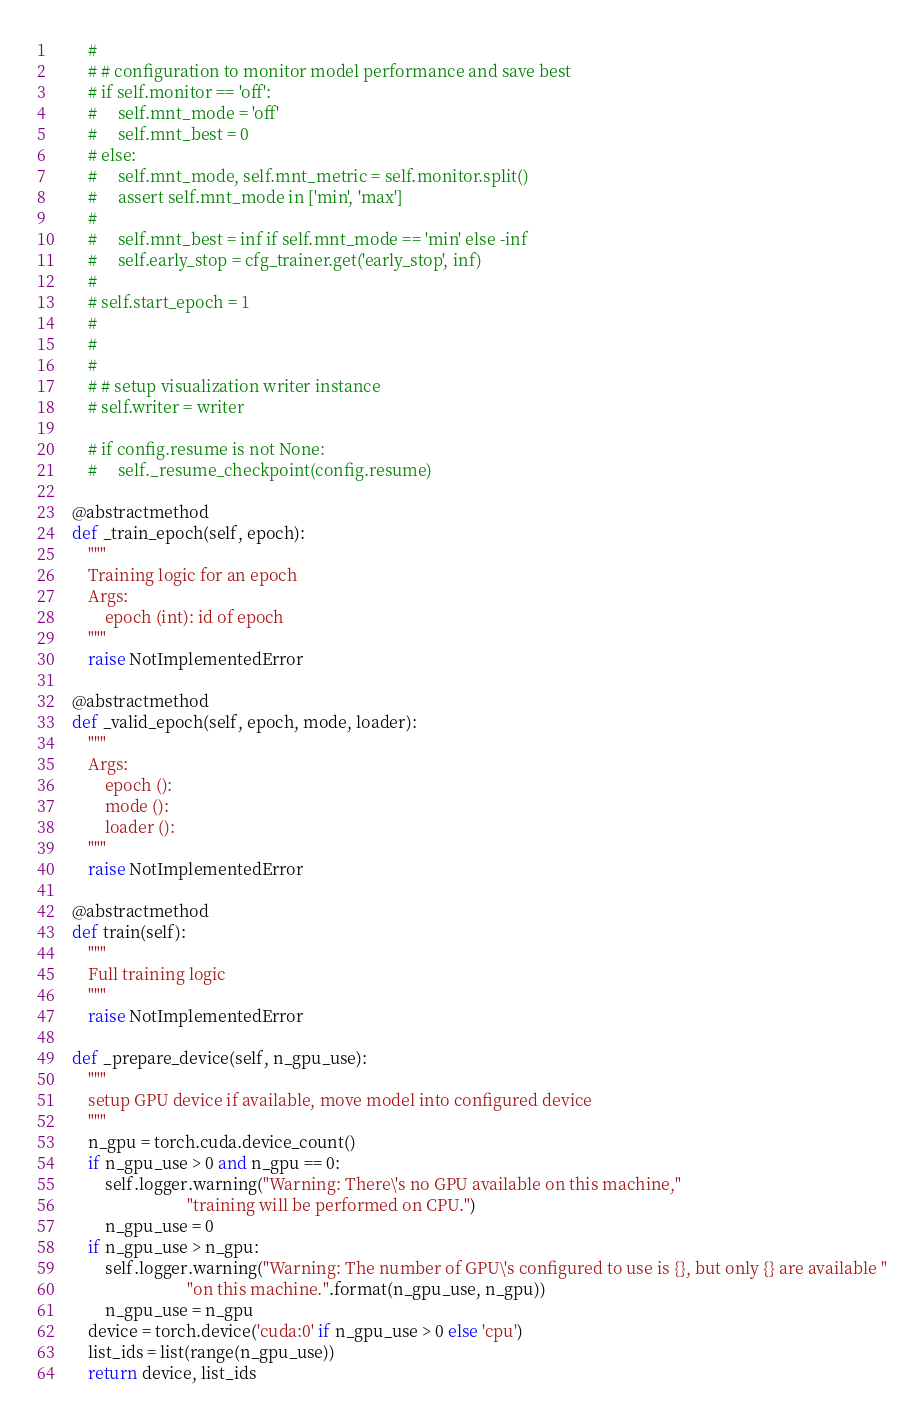<code> <loc_0><loc_0><loc_500><loc_500><_Python_>        #
        # # configuration to monitor model performance and save best
        # if self.monitor == 'off':
        #     self.mnt_mode = 'off'
        #     self.mnt_best = 0
        # else:
        #     self.mnt_mode, self.mnt_metric = self.monitor.split()
        #     assert self.mnt_mode in ['min', 'max']
        #
        #     self.mnt_best = inf if self.mnt_mode == 'min' else -inf
        #     self.early_stop = cfg_trainer.get('early_stop', inf)
        #
        # self.start_epoch = 1
        #
        #
        #
        # # setup visualization writer instance
        # self.writer = writer

        # if config.resume is not None:
        #     self._resume_checkpoint(config.resume)

    @abstractmethod
    def _train_epoch(self, epoch):
        """
        Training logic for an epoch
        Args:
            epoch (int): id of epoch
        """
        raise NotImplementedError

    @abstractmethod
    def _valid_epoch(self, epoch, mode, loader):
        """
        Args:
            epoch ():
            mode ():
            loader ():
        """
        raise NotImplementedError

    @abstractmethod
    def train(self):
        """
        Full training logic
        """
        raise NotImplementedError

    def _prepare_device(self, n_gpu_use):
        """
        setup GPU device if available, move model into configured device
        """
        n_gpu = torch.cuda.device_count()
        if n_gpu_use > 0 and n_gpu == 0:
            self.logger.warning("Warning: There\'s no GPU available on this machine,"
                                "training will be performed on CPU.")
            n_gpu_use = 0
        if n_gpu_use > n_gpu:
            self.logger.warning("Warning: The number of GPU\'s configured to use is {}, but only {} are available "
                                "on this machine.".format(n_gpu_use, n_gpu))
            n_gpu_use = n_gpu
        device = torch.device('cuda:0' if n_gpu_use > 0 else 'cpu')
        list_ids = list(range(n_gpu_use))
        return device, list_ids</code> 